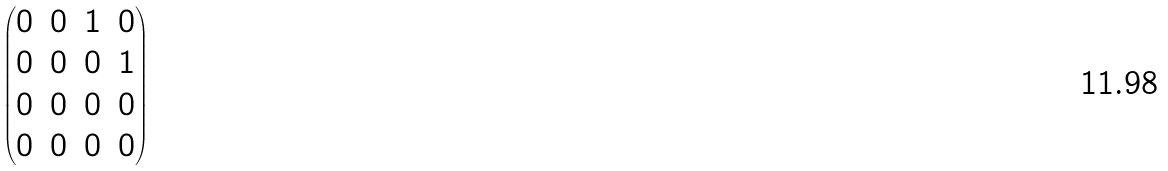<formula> <loc_0><loc_0><loc_500><loc_500>\begin{pmatrix} 0 & 0 & 1 & 0 \\ 0 & 0 & 0 & 1 \\ 0 & 0 & 0 & 0 \\ 0 & 0 & 0 & 0 \end{pmatrix}</formula> 